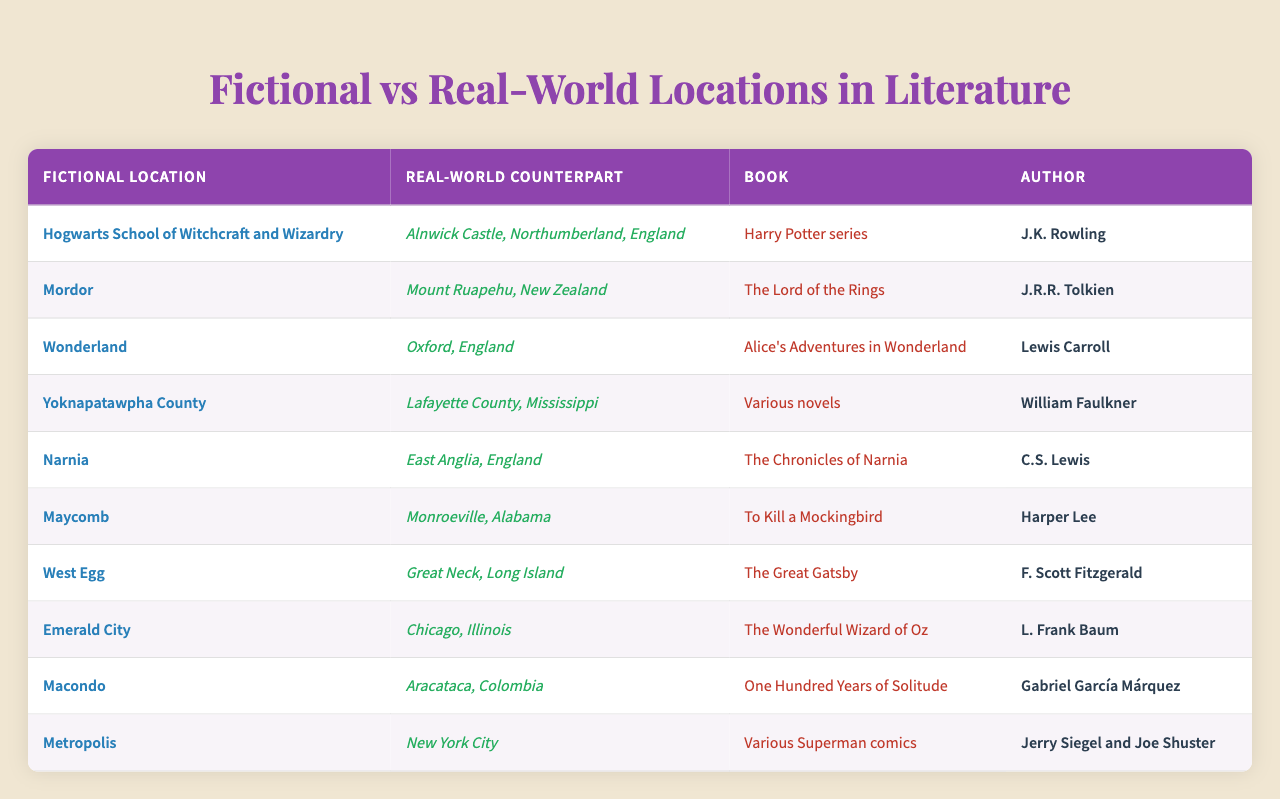What is the real-world counterpart for Hogwarts School of Witchcraft and Wizardry? The table lists "Hogwarts School of Witchcraft and Wizardry" under the fictional locations, and its real-world counterpart is noted as "Alnwick Castle, Northumberland, England."
Answer: Alnwick Castle, Northumberland, England Which author wrote about the fictional location Narnia? The table indicates that Narnia is associated with the author C.S. Lewis.
Answer: C.S. Lewis How many fictional locations are mentioned in the table? There are 10 entries in the locations list, which correspond to the count of fictional locations presented in the table.
Answer: 10 Is Maycomb a location in "The Great Gatsby"? The table shows that Maycomb is listed as a fictional location in "To Kill a Mockingbird," not in "The Great Gatsby."
Answer: No What is the fictional location associated with Mount Ruapehu? According to the table, Mount Ruapehu corresponds to the fictional location Mordor.
Answer: Mordor List two authors who have written about locations that are in England. The location data indicates that J.K. Rowling (Hogwarts) and Lewis Carroll (Wonderland) both created fictional locations based in England.
Answer: J.K. Rowling and Lewis Carroll Which book mentions the real-world counterpart Aracataca, Colombia? From the table, we see that Macondo in "One Hundred Years of Solitude" links to Aracataca, Colombia.
Answer: One Hundred Years of Solitude Are there more fictional locations in the United States or in other countries? By counting the fictional locations, we have 3 associated with the USA (Maycomb, West Egg, and Metropolis) and 4 associated with other countries (Mordor, Macondo, and others). Hence, there are more in other countries.
Answer: Other countries Identify the fictional and real-world locations mentioned in the same book, "The Lord of the Rings." The table indicates that the fictional location Mordor and its real-world counterpart Mount Ruapehu both come from "The Lord of the Rings."
Answer: Mordor and Mount Ruapehu What fraction of the fictional locations listed are set in the United Kingdom? The table indicates that there are 4 locations in the UK (Hogwarts, Wonderland, Narnia, and others) out of 10 total locations, resulting in a fraction of 4/10, which simplifies to 2/5.
Answer: 2/5 